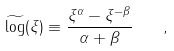Convert formula to latex. <formula><loc_0><loc_0><loc_500><loc_500>\widetilde { \log } ( \xi ) \equiv \frac { \xi ^ { \alpha } - \xi ^ { - \beta } } { \alpha + \beta } \quad ,</formula> 